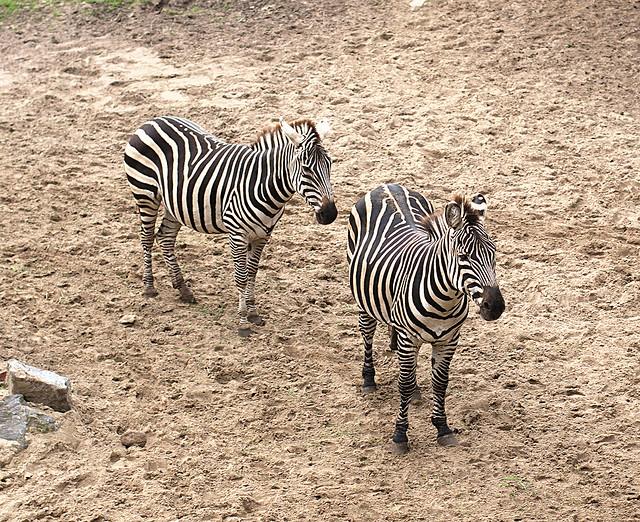How grassy is this area?
Concise answer only. Not grassy. What made the dents in the sand?
Quick response, please. Hooves. How many zebras are there?
Answer briefly. 2. 